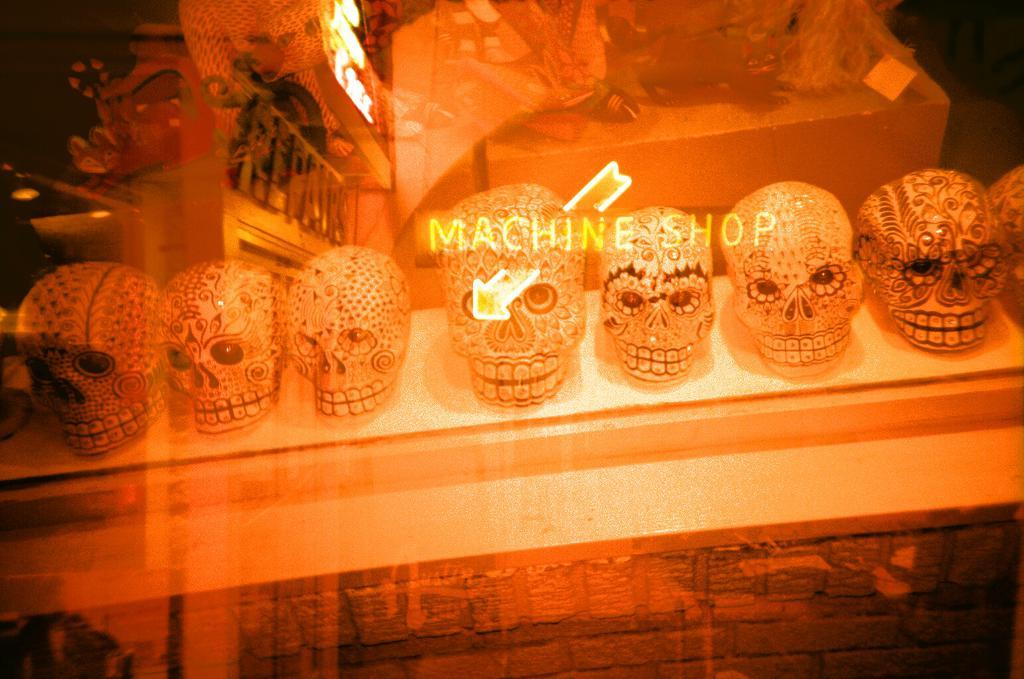What objects are on the table in the image? There are skulls on the table in the image. What is unique about the appearance of the skulls? The skulls have a design. What words can be seen on the skulls? The words "machine shop" are written on the skulls. What type of lighting is present in the image? There is an orange color light in the image. What type of corn can be seen growing on the mountain in the image? There is no corn or mountain present in the image; it features skulls on a table with a specific design and words written on them. 